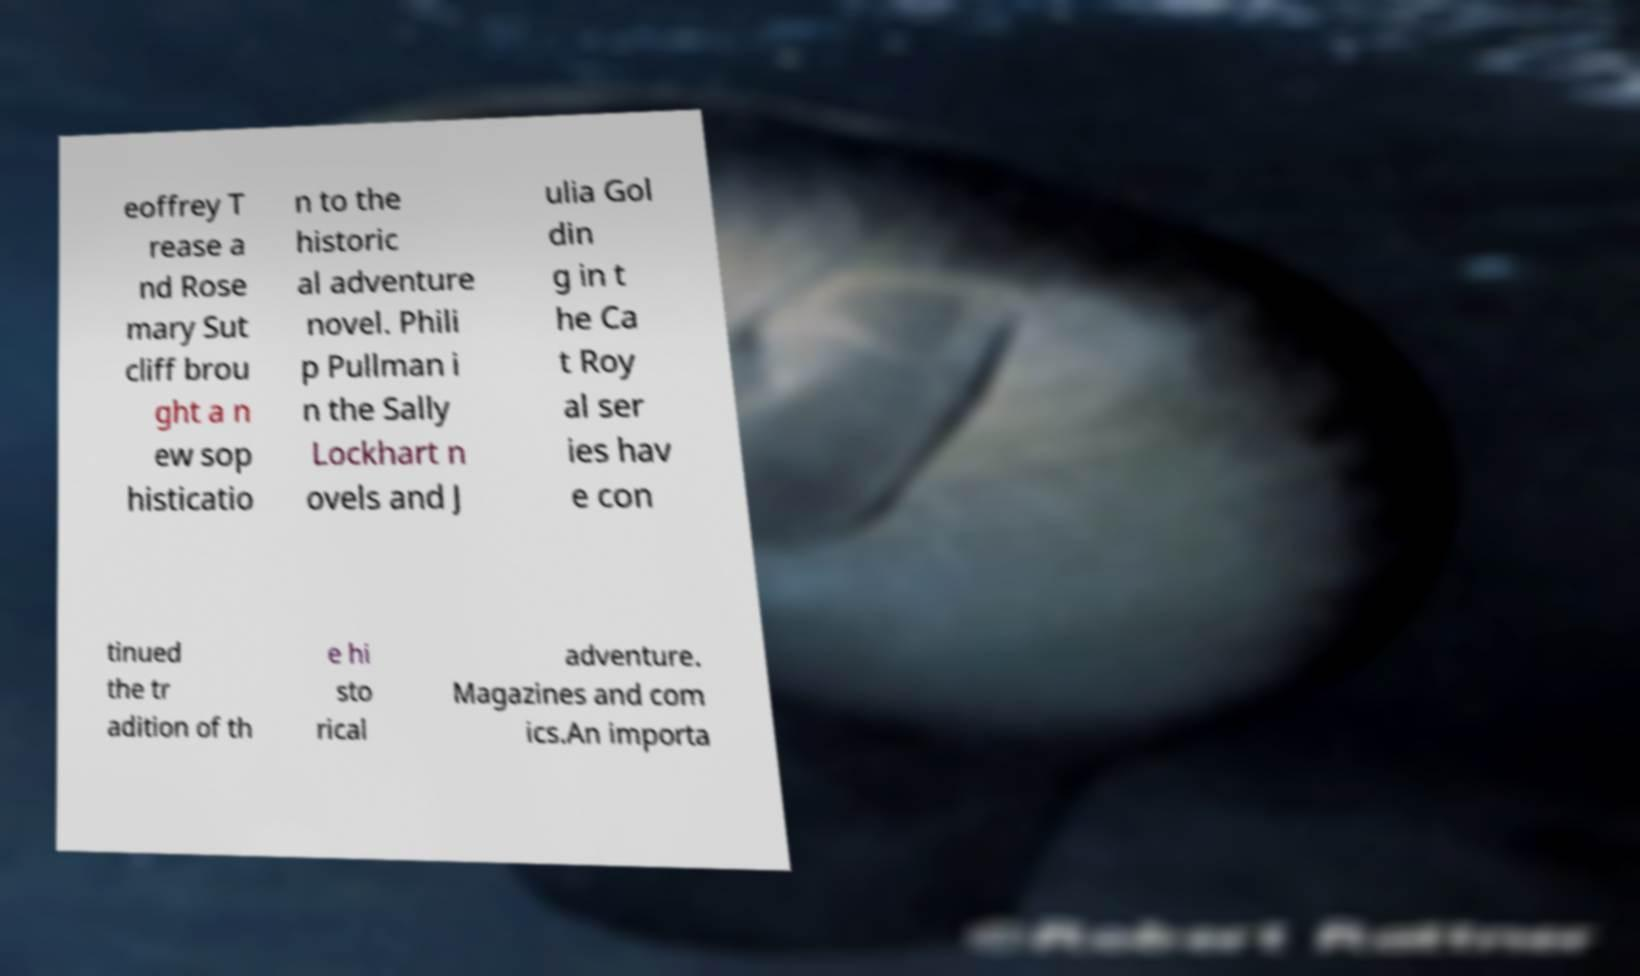Could you assist in decoding the text presented in this image and type it out clearly? eoffrey T rease a nd Rose mary Sut cliff brou ght a n ew sop histicatio n to the historic al adventure novel. Phili p Pullman i n the Sally Lockhart n ovels and J ulia Gol din g in t he Ca t Roy al ser ies hav e con tinued the tr adition of th e hi sto rical adventure. Magazines and com ics.An importa 